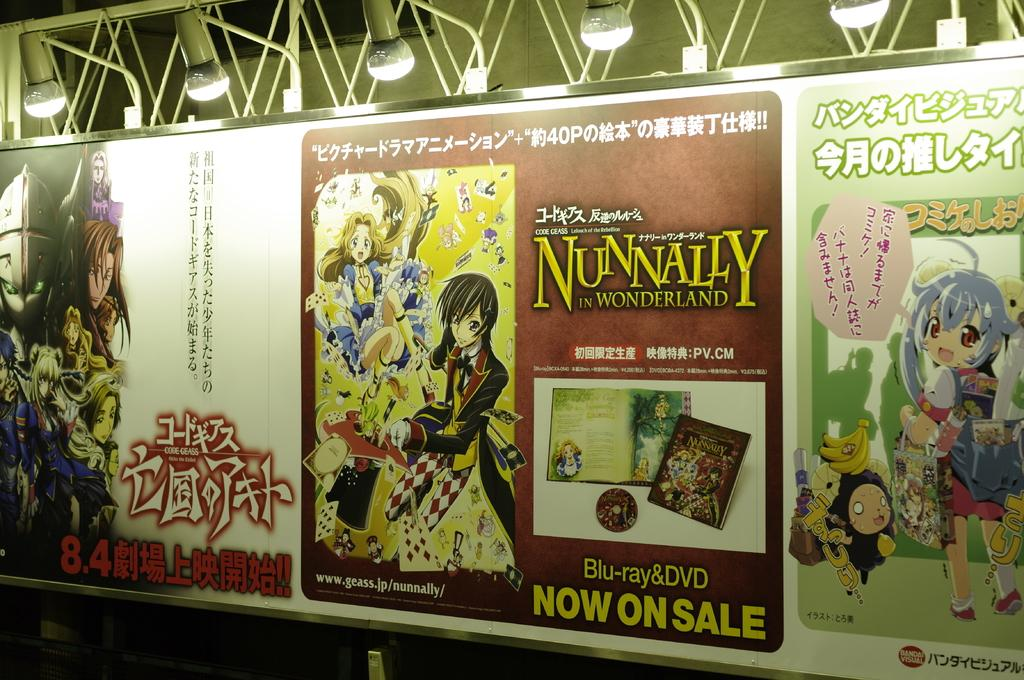<image>
Offer a succinct explanation of the picture presented. A blue ray advertisement for "NUNNALLY in WONDERLAND" is shown. 